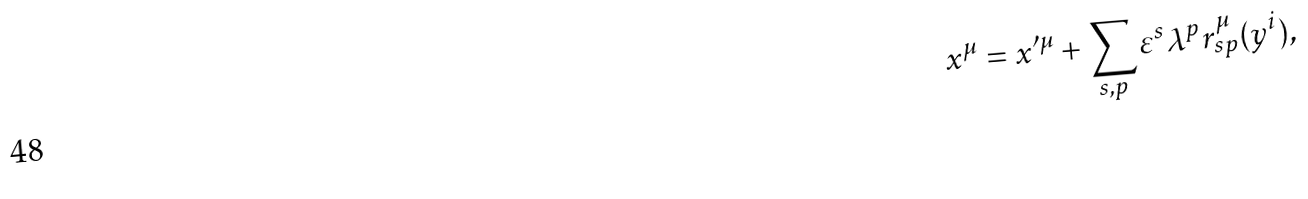<formula> <loc_0><loc_0><loc_500><loc_500>x ^ { \mu } = x ^ { \prime \mu } + \sum _ { s , p } \varepsilon ^ { s } \lambda ^ { p } r _ { s p } ^ { \mu } ( y ^ { i } ) ,</formula> 